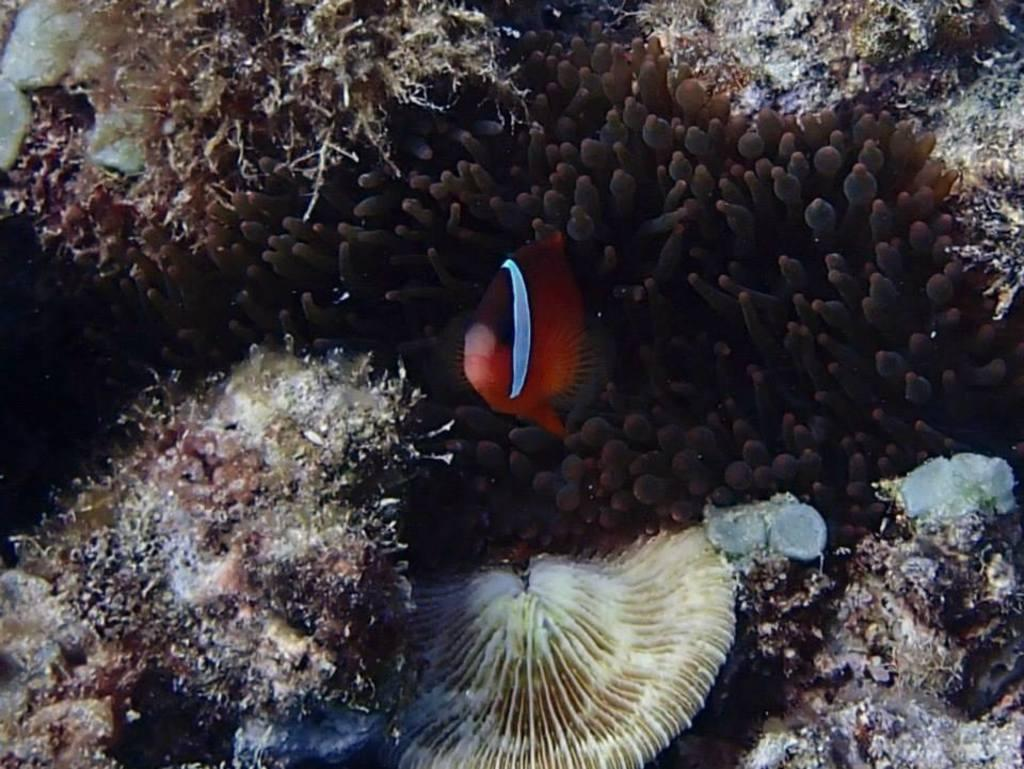What type of natural formation can be seen in the image? There are coral reefs in the image. What other living organisms are present in the image? There are fishes in the image. Where are the coral reefs and fishes located? The coral reefs and fishes are underwater. What type of knife can be seen cutting through the coral reefs in the image? There is no knife present in the image; it is a natural underwater scene with coral reefs and fishes. 